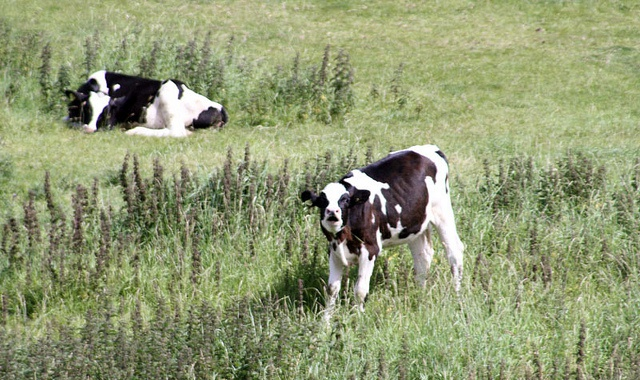Describe the objects in this image and their specific colors. I can see cow in tan, white, black, gray, and darkgray tones and cow in tan, black, white, gray, and darkgray tones in this image. 